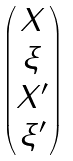<formula> <loc_0><loc_0><loc_500><loc_500>\begin{pmatrix} X \\ \xi \\ X ^ { \prime } \\ \xi ^ { \prime } \end{pmatrix}</formula> 